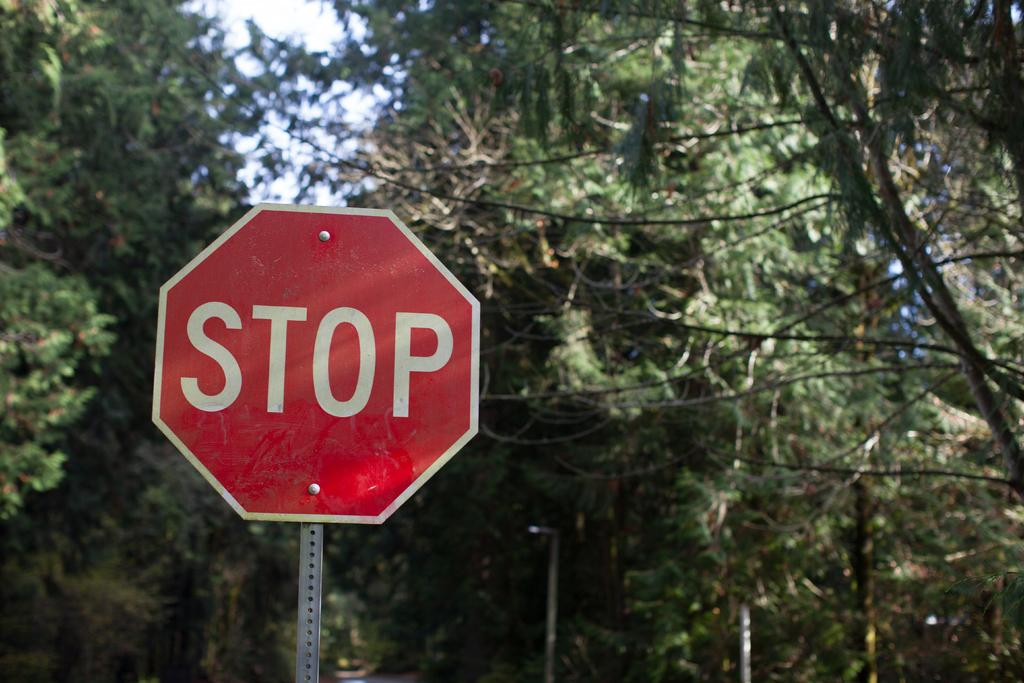Provide a one-sentence caption for the provided image. A STOP sign in the middle of a pine forrest. 